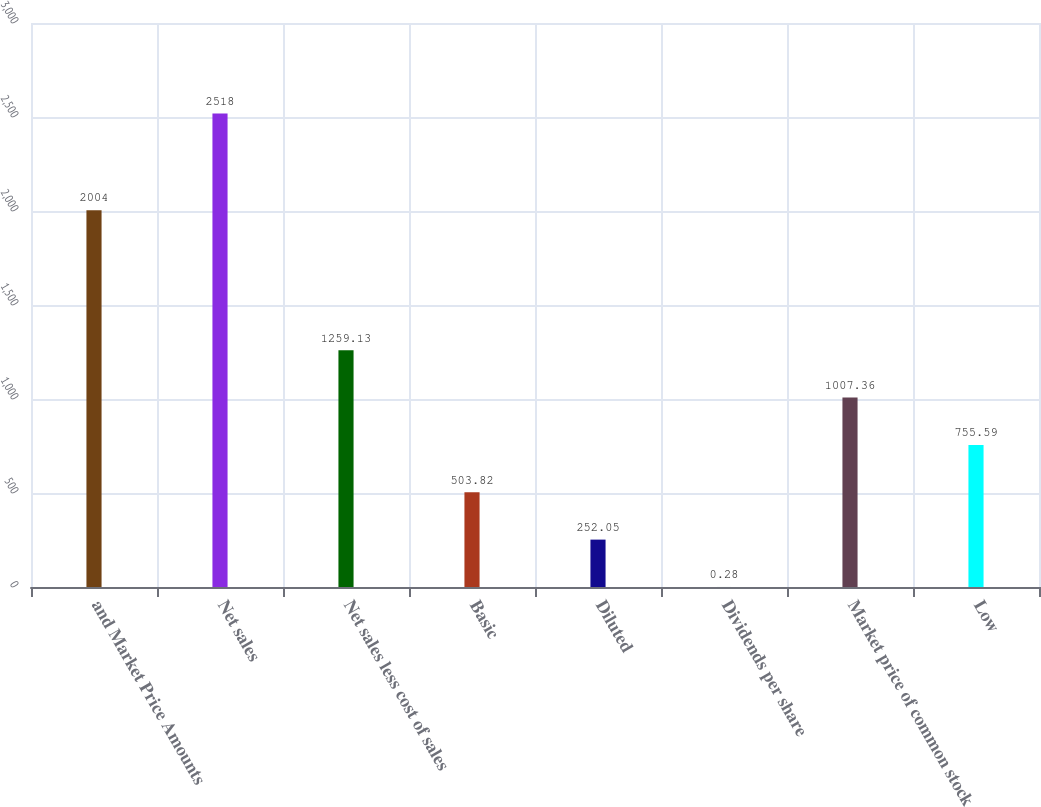Convert chart. <chart><loc_0><loc_0><loc_500><loc_500><bar_chart><fcel>and Market Price Amounts<fcel>Net sales<fcel>Net sales less cost of sales<fcel>Basic<fcel>Diluted<fcel>Dividends per share<fcel>Market price of common stock<fcel>Low<nl><fcel>2004<fcel>2518<fcel>1259.13<fcel>503.82<fcel>252.05<fcel>0.28<fcel>1007.36<fcel>755.59<nl></chart> 